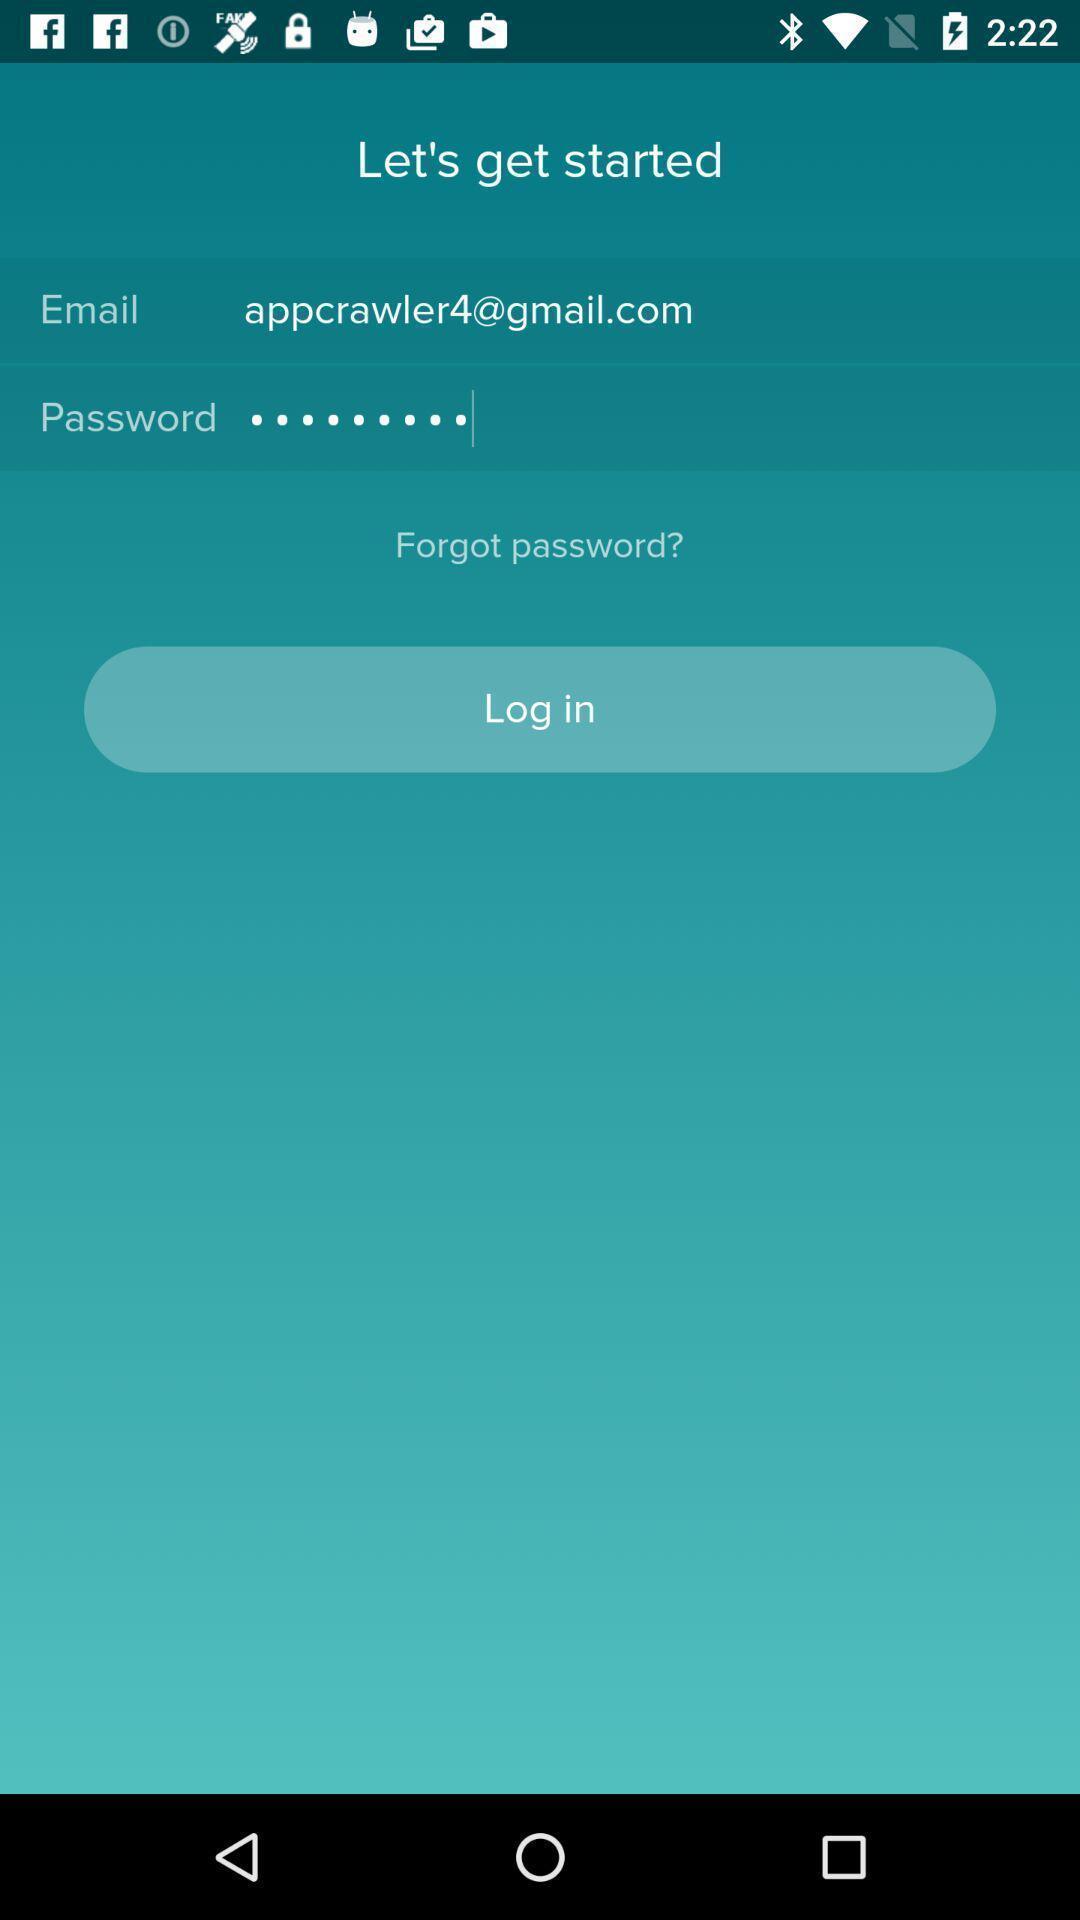Describe the visual elements of this screenshot. Login page. 